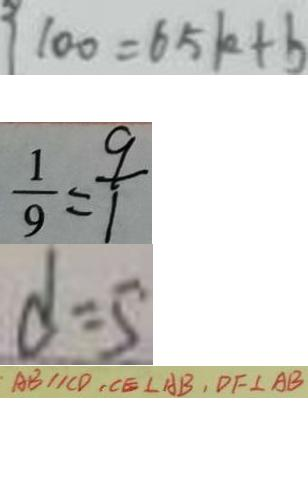Convert formula to latex. <formula><loc_0><loc_0><loc_500><loc_500>1 0 0 = 6 5 k + b 
 \frac { 1 } { 9 } = \frac { 9 } { 1 } 
 d = 5 
 \cdot A B / / C D , C E \bot A B , D F \bot A B</formula> 